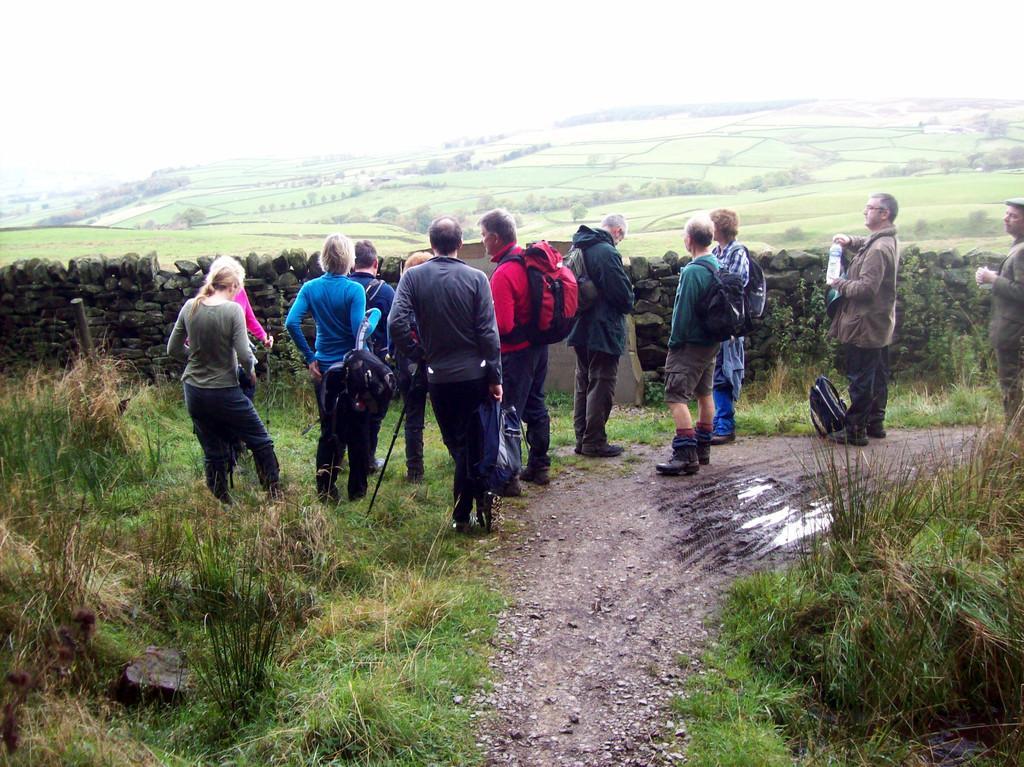How would you summarize this image in a sentence or two? In this image I can see people are standing among them some are carrying bags. Here I can see the water and a fence wall. In the background I can see the grass, trees and the sky. 